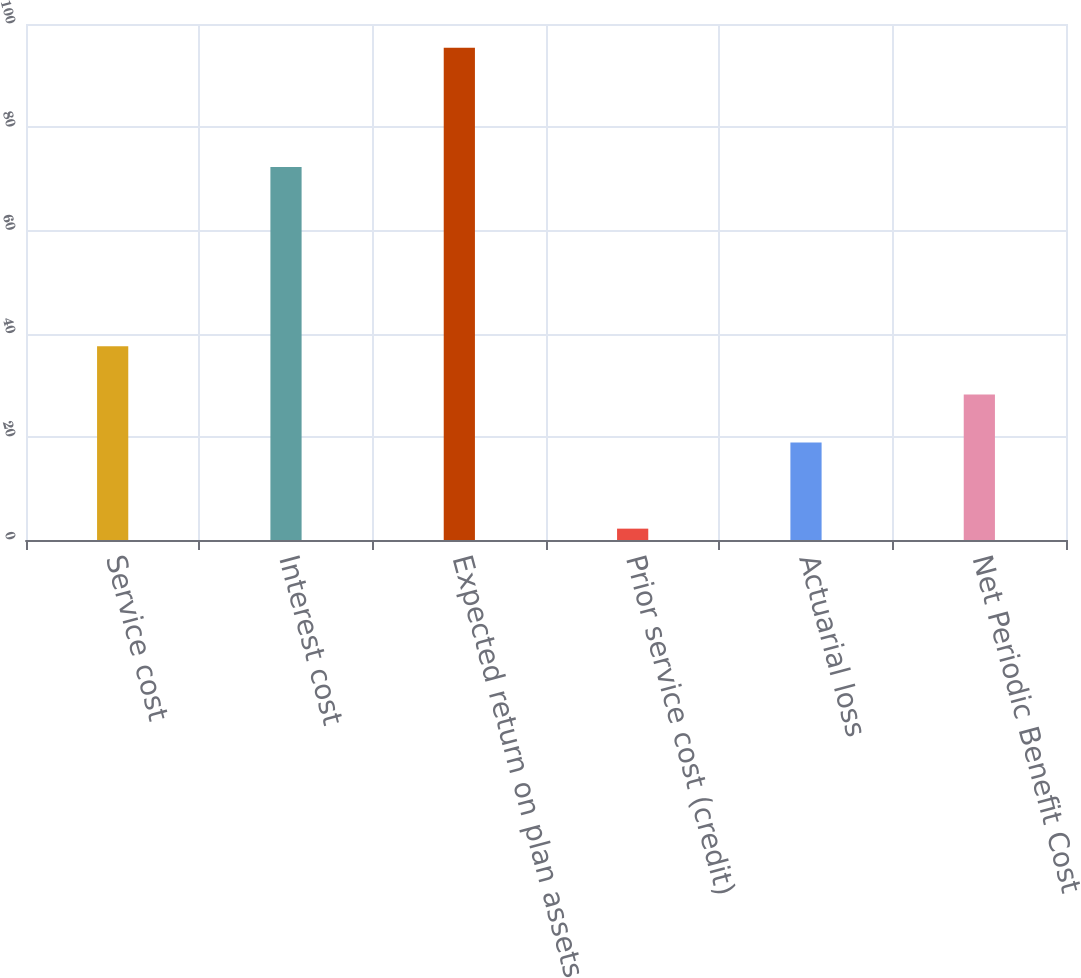Convert chart. <chart><loc_0><loc_0><loc_500><loc_500><bar_chart><fcel>Service cost<fcel>Interest cost<fcel>Expected return on plan assets<fcel>Prior service cost (credit)<fcel>Actuarial loss<fcel>Net Periodic Benefit Cost<nl><fcel>37.54<fcel>72.3<fcel>95.4<fcel>2.2<fcel>18.9<fcel>28.22<nl></chart> 